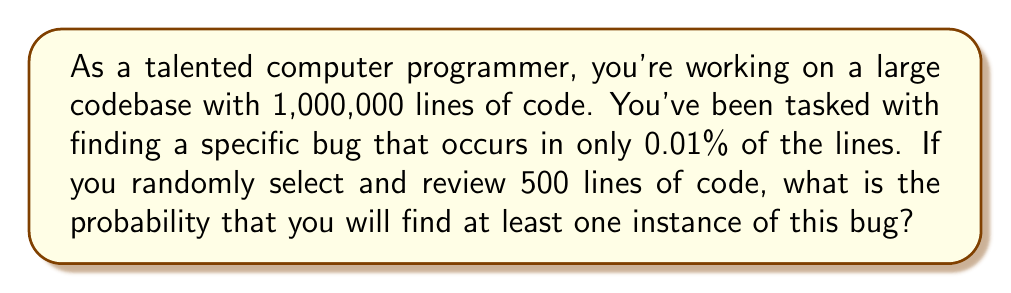Can you solve this math problem? Let's approach this step-by-step:

1) First, let's calculate the probability of a single line containing the bug:
   $p = 0.01\% = 0.0001$

2) The probability of a single line not containing the bug is:
   $1 - p = 0.9999$

3) We want to find the probability of finding at least one instance of the bug in 500 lines. This is equivalent to 1 minus the probability of not finding the bug in any of the 500 lines.

4) The probability of not finding the bug in all 500 lines is:
   $(0.9999)^{500}$

5) Therefore, the probability of finding at least one instance of the bug is:
   $1 - (0.9999)^{500}$

6) Let's calculate this:
   $1 - (0.9999)^{500} = 1 - 0.9512 = 0.0488$

7) Converting to a percentage:
   $0.0488 * 100\% = 4.88\%$

This means there's approximately a 4.88% chance of finding at least one instance of the bug when randomly selecting and reviewing 500 lines of code.
Answer: The probability of finding at least one instance of the bug when randomly selecting and reviewing 500 lines of code is approximately 4.88% or 0.0488. 